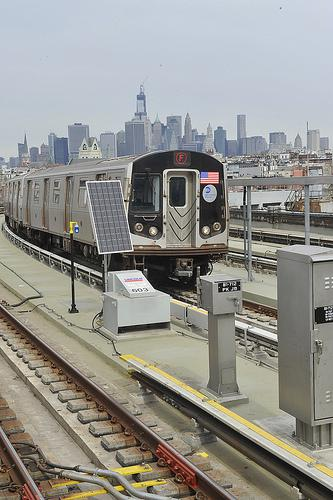Question: who is in the photo?
Choices:
A. Three men.
B. Two children.
C. No one.
D. A huge crowd.
Answer with the letter. Answer: C Question: what is in the center of the photo?
Choices:
A. A train.
B. A fountain.
C. A statue.
D. A skyscraper.
Answer with the letter. Answer: A Question: what is the train made of?
Choices:
A. Wood.
B. Metal.
C. Plasic.
D. Porceline.
Answer with the letter. Answer: B Question: what is in the background?
Choices:
A. A barn.
B. Buildings.
C. A house.
D. A field.
Answer with the letter. Answer: B Question: when was the photo taken?
Choices:
A. At night.
B. During the day.
C. In the afternoon.
D. In the morning.
Answer with the letter. Answer: B 